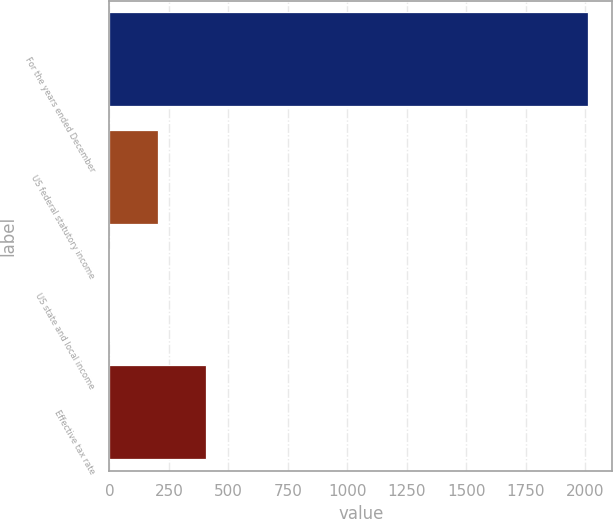Convert chart. <chart><loc_0><loc_0><loc_500><loc_500><bar_chart><fcel>For the years ended December<fcel>US federal statutory income<fcel>US state and local income<fcel>Effective tax rate<nl><fcel>2013<fcel>203.01<fcel>1.9<fcel>404.12<nl></chart> 